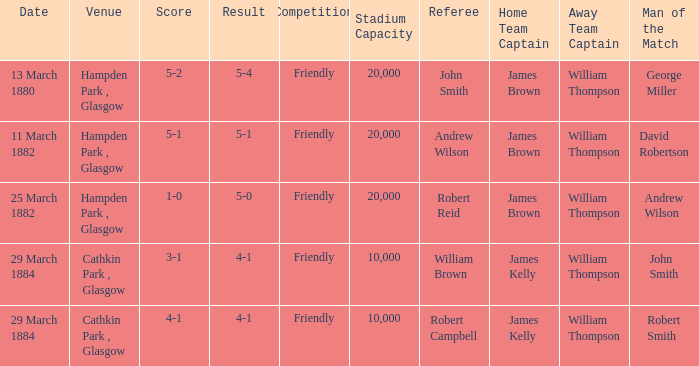Which item has a score of 5-1? 5-1. 